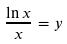<formula> <loc_0><loc_0><loc_500><loc_500>\frac { \ln x } { x } = y</formula> 